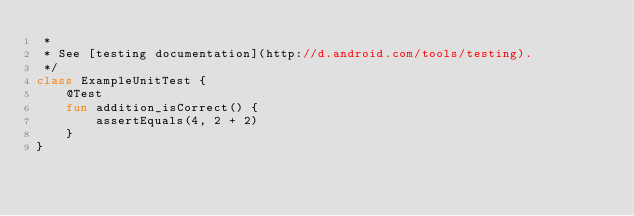<code> <loc_0><loc_0><loc_500><loc_500><_Kotlin_> *
 * See [testing documentation](http://d.android.com/tools/testing).
 */
class ExampleUnitTest {
    @Test
    fun addition_isCorrect() {
        assertEquals(4, 2 + 2)
    }
}</code> 